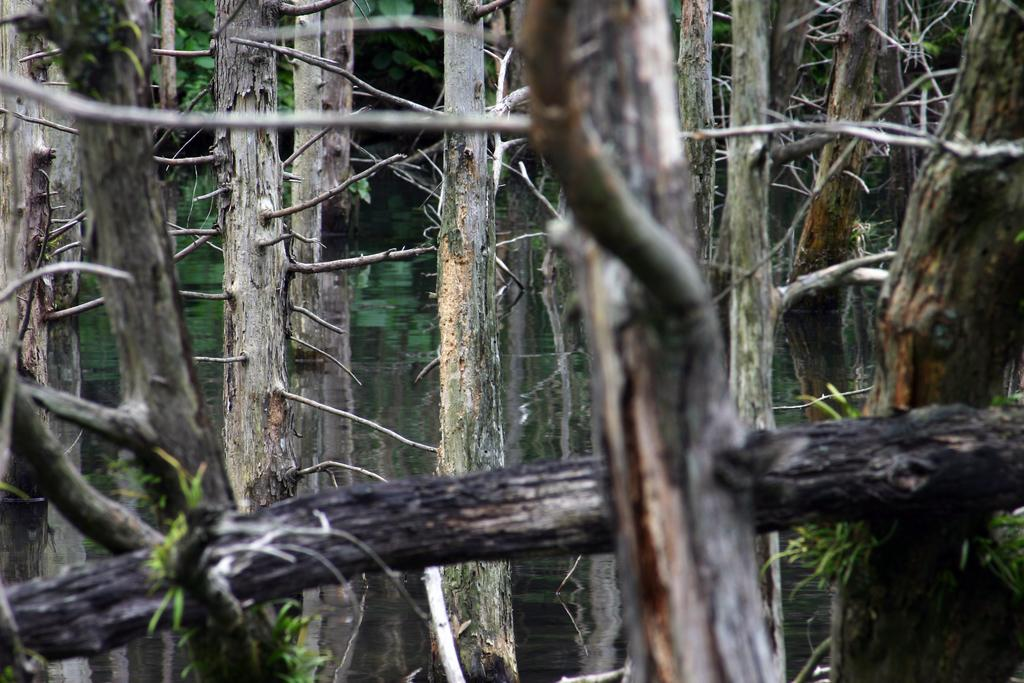What type of trees can be seen in the image? There are dried trees in the image. Are there any other types of trees visible in the image? Yes, there are green trees in the background of the image. What color is the zipper on the drawer in the image? There is no zipper or drawer present in the image. 